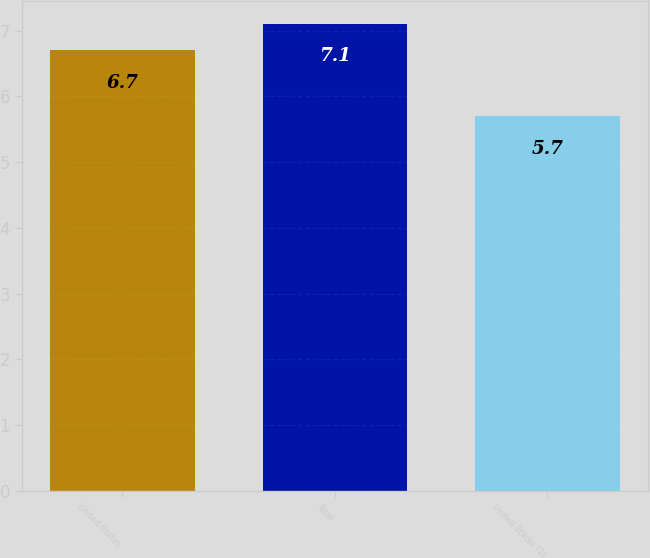Convert chart. <chart><loc_0><loc_0><loc_500><loc_500><bar_chart><fcel>United States<fcel>Total<fcel>United States (1)<nl><fcel>6.7<fcel>7.1<fcel>5.7<nl></chart> 